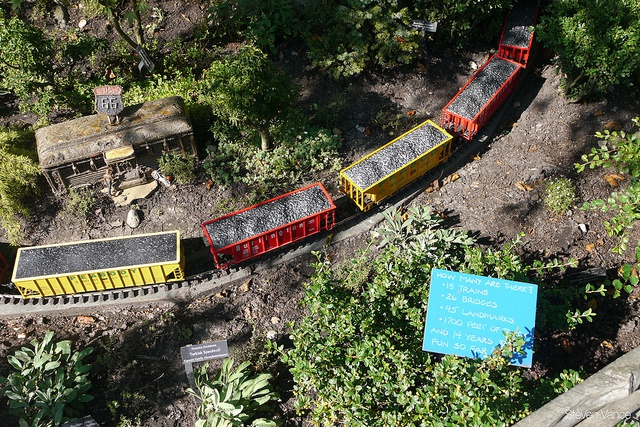Describe the objects in this image and their specific colors. I can see train in black, gray, darkgray, and maroon tones and people in black, tan, darkgray, and gray tones in this image. 